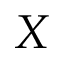Convert formula to latex. <formula><loc_0><loc_0><loc_500><loc_500>X</formula> 